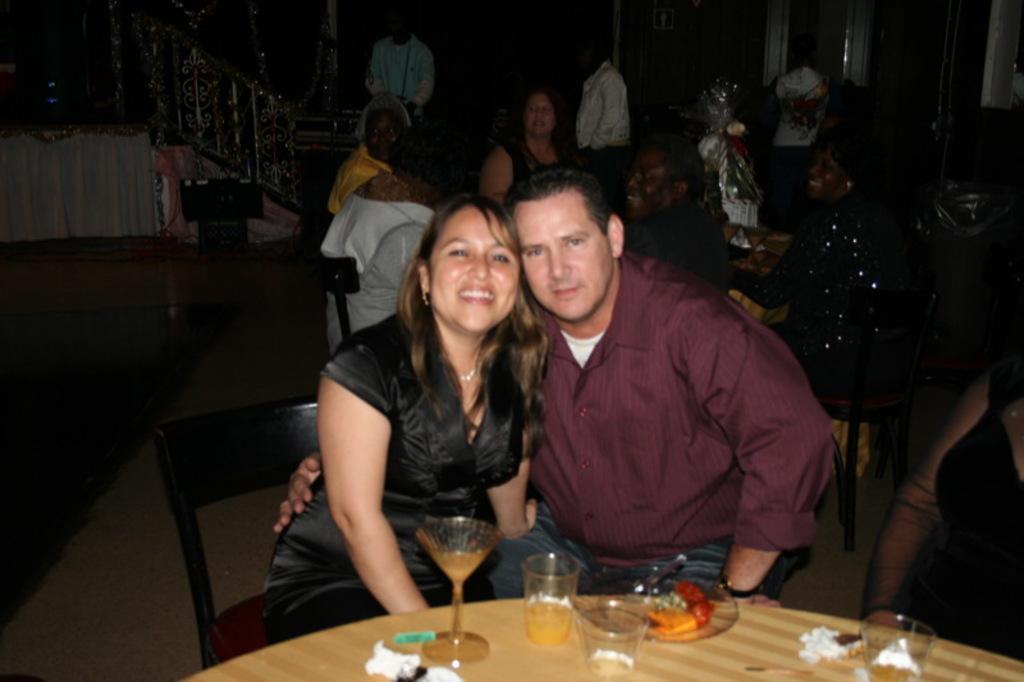Describe this image in one or two sentences. In this image I can see two people sitting in-front of the table. On the table there is a plate,glasses. In the back ground there are group of people and also a railing. 